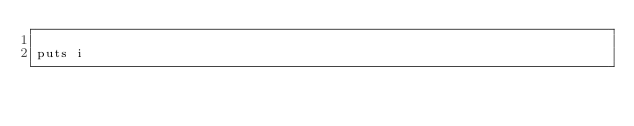<code> <loc_0><loc_0><loc_500><loc_500><_Ruby_>
puts i</code> 